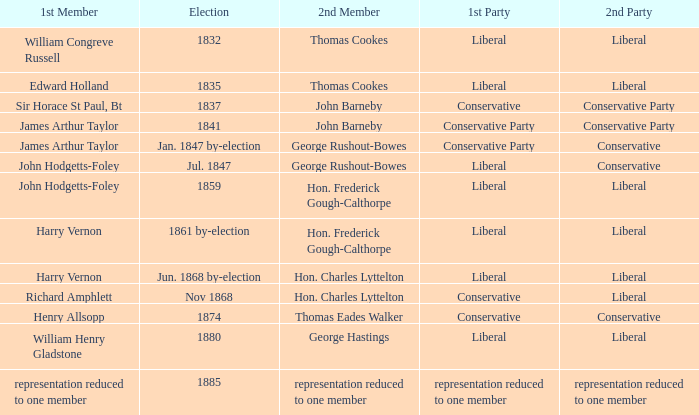What was the 2nd Party when its 2nd Member was George Rushout-Bowes, and the 1st Party was Liberal? Conservative. 